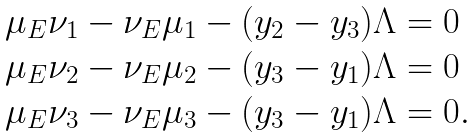<formula> <loc_0><loc_0><loc_500><loc_500>\begin{array} { l l } \mu _ { E } \nu _ { 1 } - \nu _ { E } \mu _ { 1 } - ( y _ { 2 } - y _ { 3 } ) \Lambda = 0 \\ \mu _ { E } \nu _ { 2 } - \nu _ { E } \mu _ { 2 } - ( y _ { 3 } - y _ { 1 } ) \Lambda = 0 \\ \mu _ { E } \nu _ { 3 } - \nu _ { E } \mu _ { 3 } - ( y _ { 3 } - y _ { 1 } ) \Lambda = 0 . \end{array}</formula> 